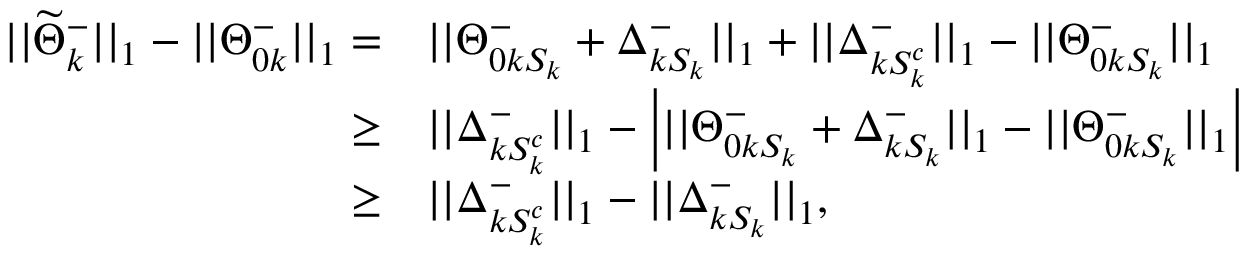<formula> <loc_0><loc_0><loc_500><loc_500>\begin{array} { r l } { | | \widetilde { \Theta } _ { k } ^ { - } | | _ { 1 } - | | { \Theta } _ { 0 k } ^ { - } | | _ { 1 } = } & { | | { \Theta } _ { 0 k S _ { k } } ^ { - } + \Delta _ { k S _ { k } } ^ { - } | | _ { 1 } + | | \Delta _ { k S _ { k } ^ { c } } ^ { - } | | _ { 1 } - | | { \Theta } _ { 0 k S _ { k } } ^ { - } | | _ { 1 } } \\ { \geq } & { | | \Delta _ { k S _ { k } ^ { c } } ^ { - } | | _ { 1 } - \left | | | { \Theta } _ { 0 k S _ { k } } ^ { - } + \Delta _ { k S _ { k } } ^ { - } | | _ { 1 } - | | { \Theta } _ { 0 k S _ { k } } ^ { - } | | _ { 1 } \right | } \\ { \geq } & { | | \Delta _ { k S _ { k } ^ { c } } ^ { - } | | _ { 1 } - | | \Delta _ { k S _ { k } } ^ { - } | | _ { 1 } , } \end{array}</formula> 